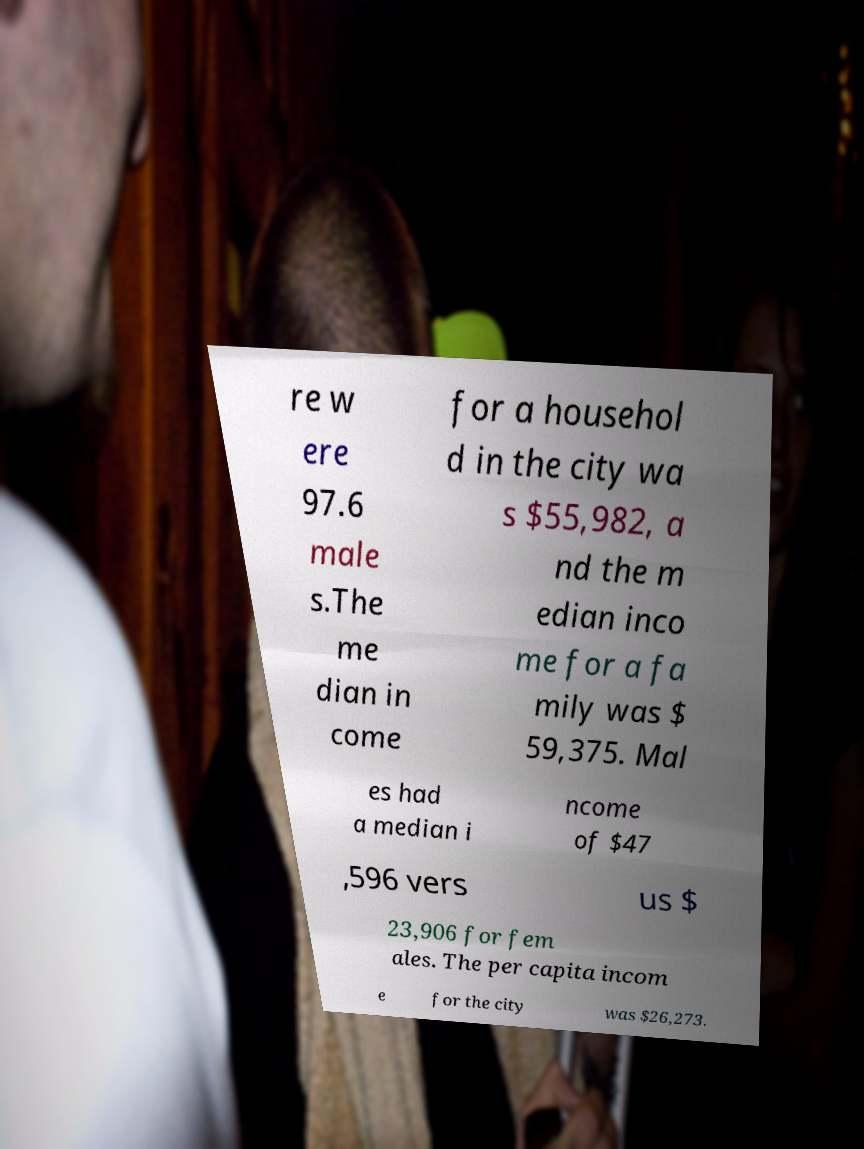Please identify and transcribe the text found in this image. re w ere 97.6 male s.The me dian in come for a househol d in the city wa s $55,982, a nd the m edian inco me for a fa mily was $ 59,375. Mal es had a median i ncome of $47 ,596 vers us $ 23,906 for fem ales. The per capita incom e for the city was $26,273. 